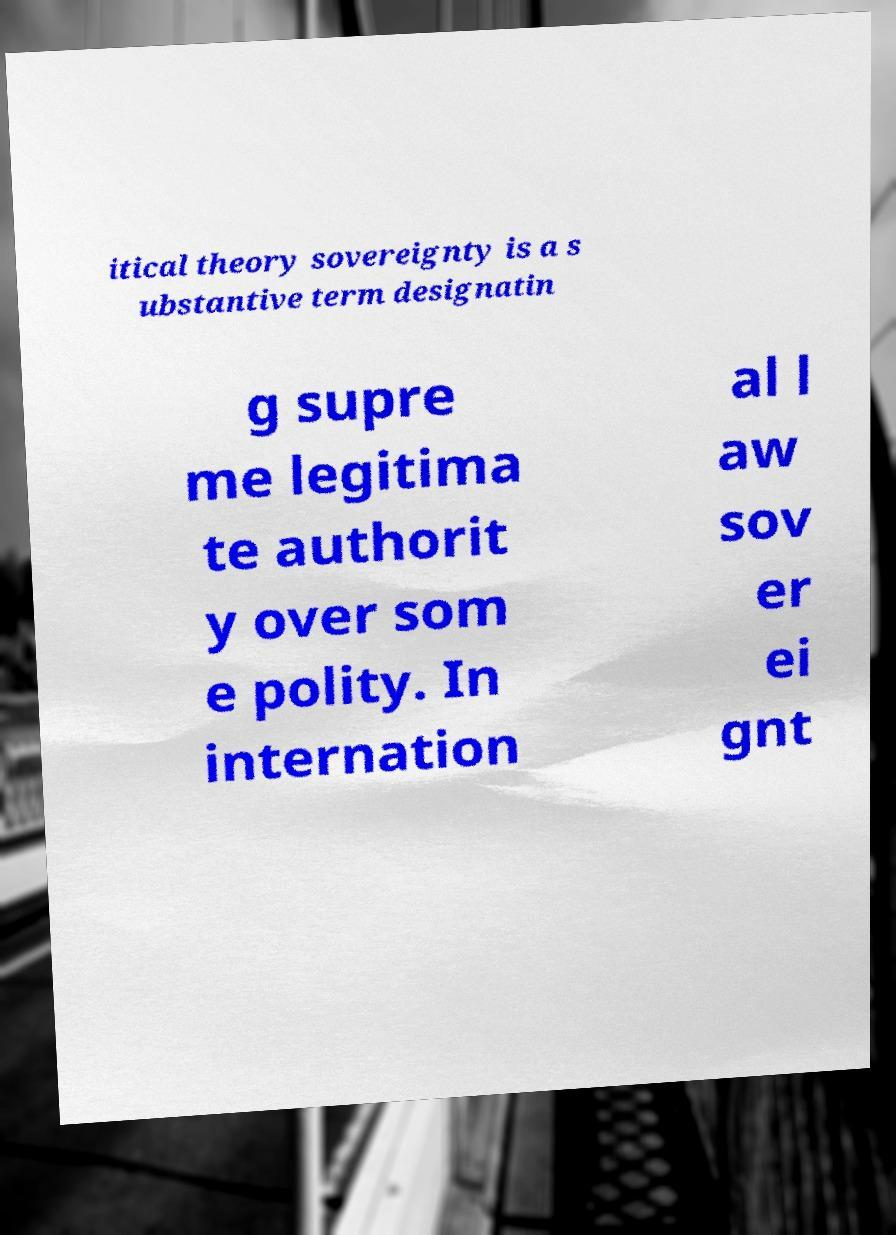Please read and relay the text visible in this image. What does it say? itical theory sovereignty is a s ubstantive term designatin g supre me legitima te authorit y over som e polity. In internation al l aw sov er ei gnt 